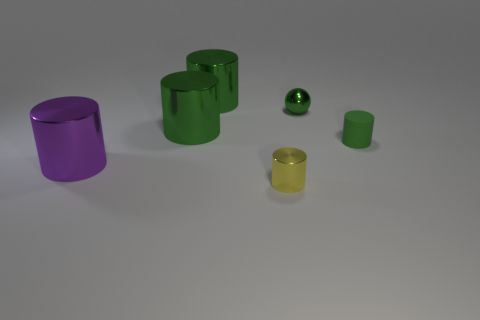How many green cylinders must be subtracted to get 1 green cylinders? 2 Subtract all blue cubes. How many green cylinders are left? 3 Subtract all small yellow metallic cylinders. How many cylinders are left? 4 Subtract all yellow cylinders. How many cylinders are left? 4 Add 3 big gray metallic cylinders. How many objects exist? 9 Subtract all blue cylinders. Subtract all cyan blocks. How many cylinders are left? 5 Subtract all balls. How many objects are left? 5 Subtract 0 blue balls. How many objects are left? 6 Subtract all green cylinders. Subtract all small cyan shiny cylinders. How many objects are left? 3 Add 6 yellow things. How many yellow things are left? 7 